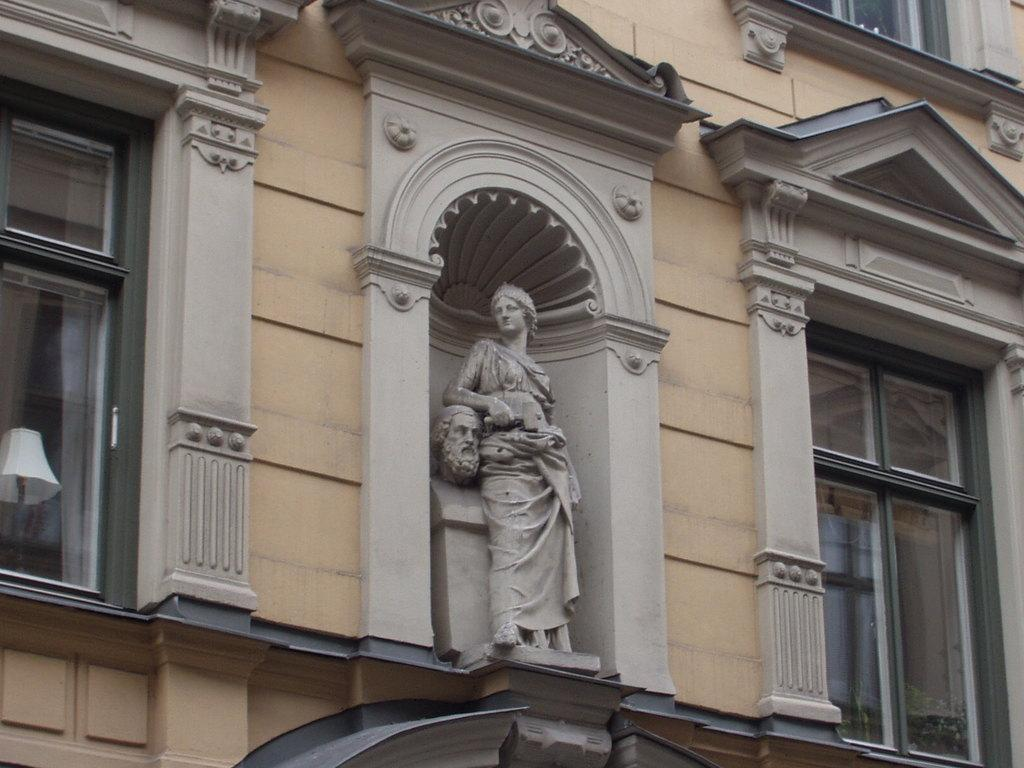What is the main structure visible in the image? There is a building in the image. What is located in the middle of the building? The building has a sculpture in the middle. What type of windows are present on the building? The building has glass windows beside the sculpture. What type of owl can be seen perched on the sculpture in the image? There is no owl present in the image; the sculpture is the main focus in the middle of the building. 